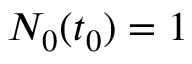<formula> <loc_0><loc_0><loc_500><loc_500>N _ { 0 } ( t _ { 0 } ) = 1</formula> 